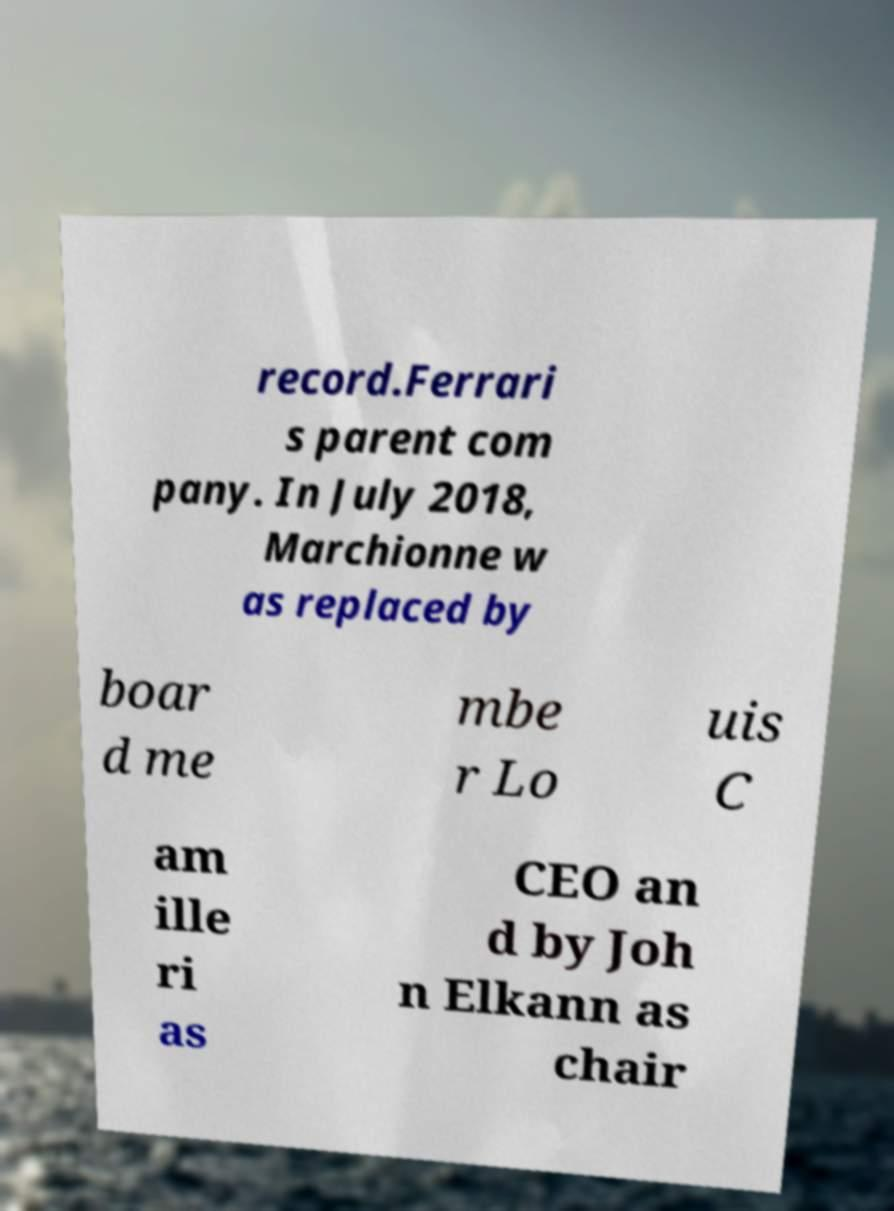What messages or text are displayed in this image? I need them in a readable, typed format. record.Ferrari s parent com pany. In July 2018, Marchionne w as replaced by boar d me mbe r Lo uis C am ille ri as CEO an d by Joh n Elkann as chair 